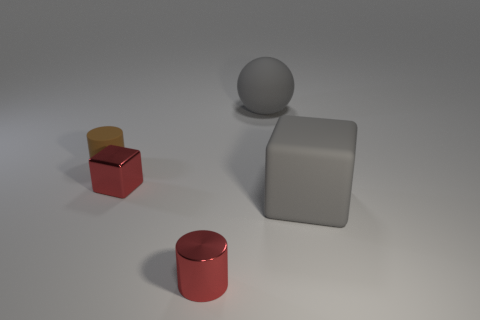Subtract all gray cylinders. Subtract all brown balls. How many cylinders are left? 2 Add 2 big gray matte spheres. How many objects exist? 7 Subtract all balls. How many objects are left? 4 Add 5 tiny red blocks. How many tiny red blocks exist? 6 Subtract 0 green cubes. How many objects are left? 5 Subtract all tiny gray shiny balls. Subtract all small blocks. How many objects are left? 4 Add 4 gray matte balls. How many gray matte balls are left? 5 